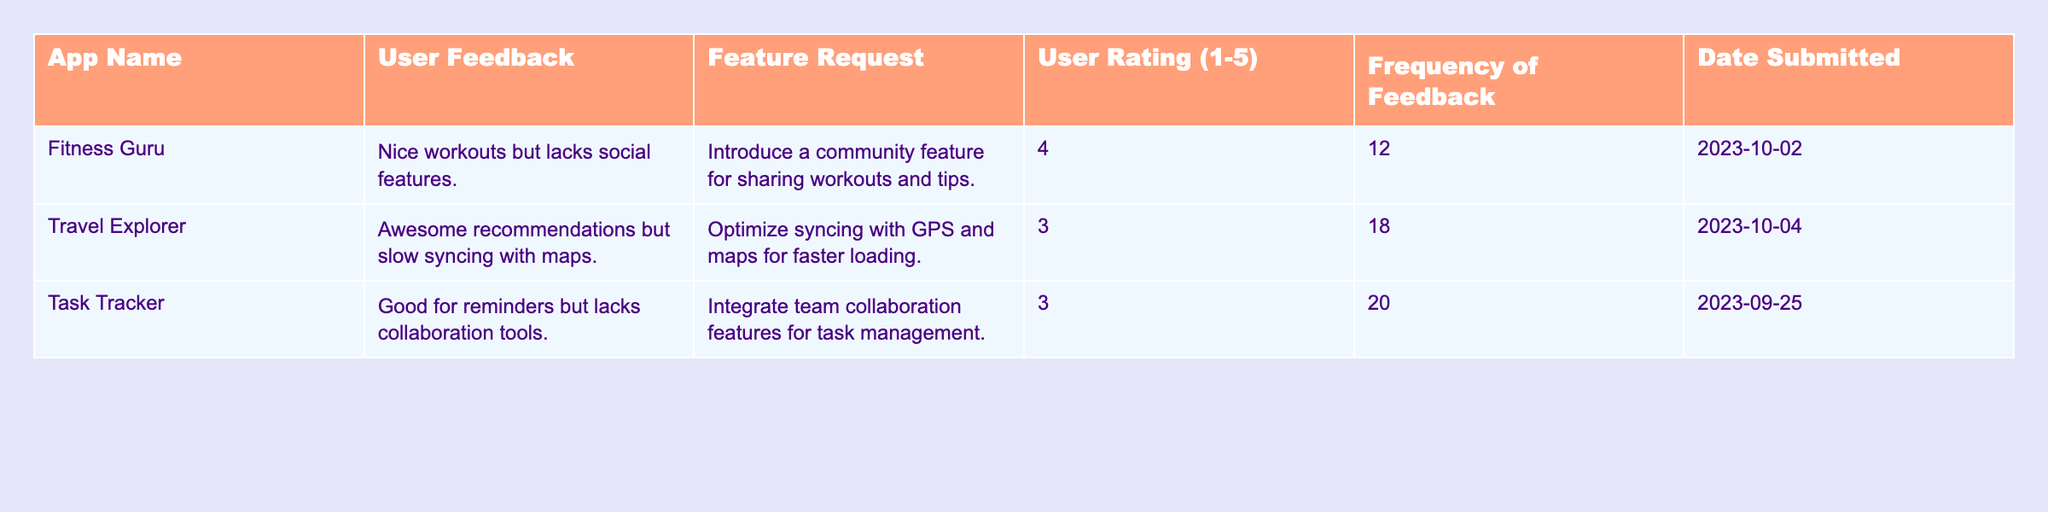What is the user rating for the "Travel Explorer" app? The user rating is listed in the "User Rating" column for the "Travel Explorer" row. It shows a rating of 3.
Answer: 3 Which app received the highest frequency of feedback? By checking the "Frequency of Feedback" column, the "Task Tracker" app has the highest frequency at 20.
Answer: Task Tracker Are there any apps that have a user rating of 5? A review of the "User Rating" column shows there are no apps with a rating of 5.
Answer: No What is the average frequency of feedback for all apps listed? To find the average, add the frequencies: (12 + 18 + 20) = 50. There are 3 apps, so the average is 50 / 3 = 16.67.
Answer: 16.67 Does the "Fitness Guru" app have any feature requests listed? The "Fitness Guru" row includes a specific feature request in the "Feature Request" column, indicating it does have a request.
Answer: Yes Which app has received feedback regarding collaboration tools? The "Task Tracker" app mentions a lack of collaboration tools in its user feedback section.
Answer: Task Tracker What is the sum of all user ratings for the apps listed? To find the sum, add the user ratings together: (4 + 3 + 3) = 10.
Answer: 10 What feature request was made for the "Fitness Guru" app? The request listed in the "Feature Request" column for "Fitness Guru" is to introduce a community feature.
Answer: Introduce a community feature Which app has the earliest submission date for feedback? Looking at the "Date Submitted" column, "Task Tracker" is the earliest entry with a date of 2023-09-25.
Answer: Task Tracker Is there a feature request for optimizing GPS and maps made for any app? The "Travel Explorer" app has a feature request that specifically mentions optimizing syncing with GPS and maps.
Answer: Yes 